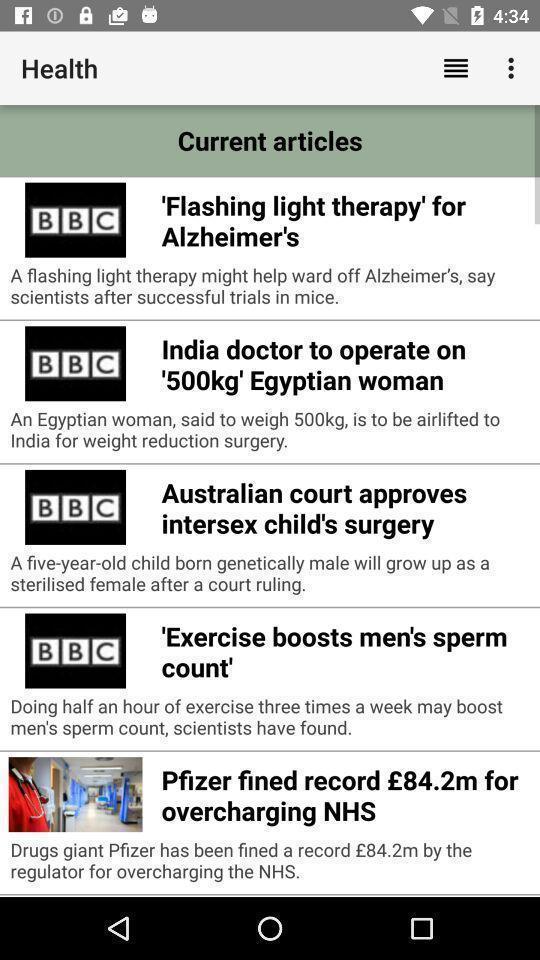Tell me about the visual elements in this screen capture. Page displaying list of articles. 